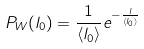<formula> <loc_0><loc_0><loc_500><loc_500>P _ { W } ( l _ { 0 } ) = \frac { 1 } { \langle l _ { 0 } \rangle } e ^ { - \frac { l } { \langle l _ { 0 } \rangle } }</formula> 